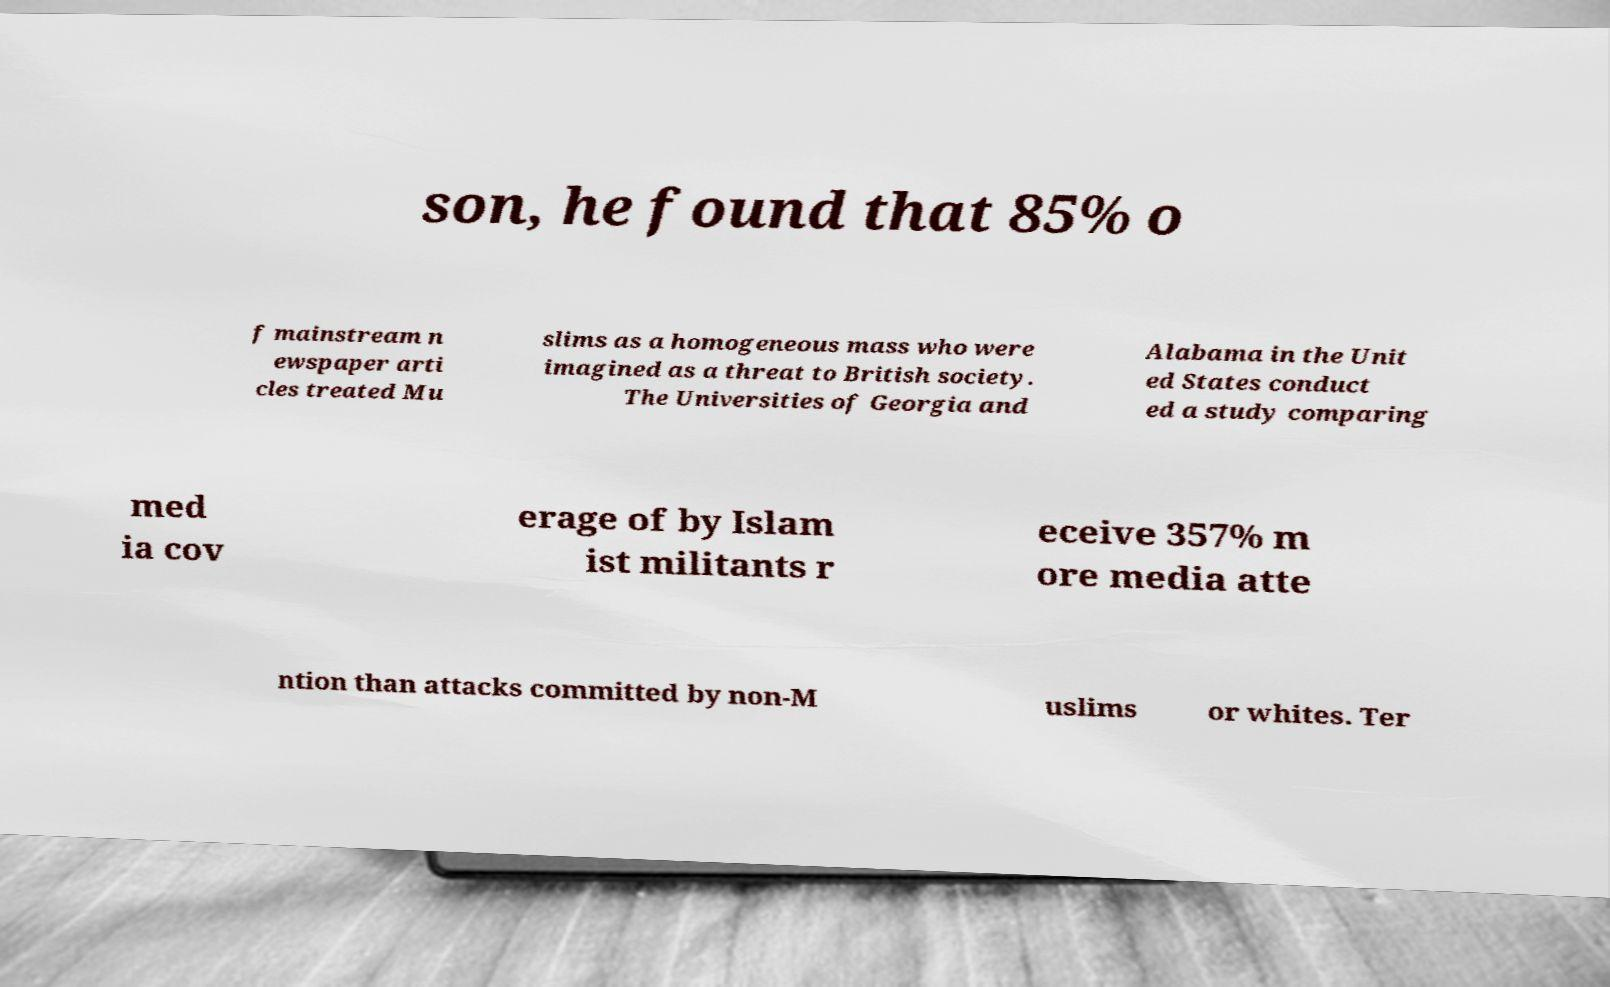Can you accurately transcribe the text from the provided image for me? son, he found that 85% o f mainstream n ewspaper arti cles treated Mu slims as a homogeneous mass who were imagined as a threat to British society. The Universities of Georgia and Alabama in the Unit ed States conduct ed a study comparing med ia cov erage of by Islam ist militants r eceive 357% m ore media atte ntion than attacks committed by non-M uslims or whites. Ter 